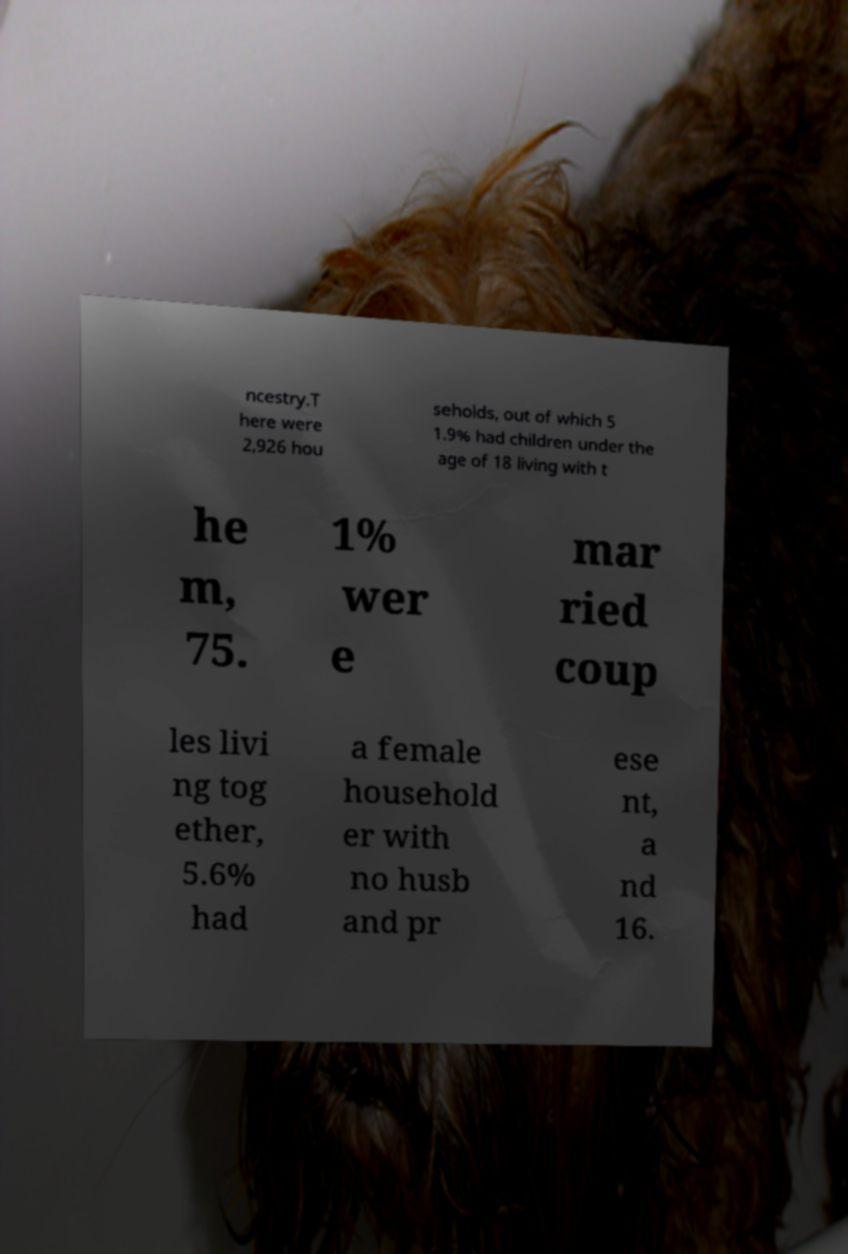Please read and relay the text visible in this image. What does it say? ncestry.T here were 2,926 hou seholds, out of which 5 1.9% had children under the age of 18 living with t he m, 75. 1% wer e mar ried coup les livi ng tog ether, 5.6% had a female household er with no husb and pr ese nt, a nd 16. 